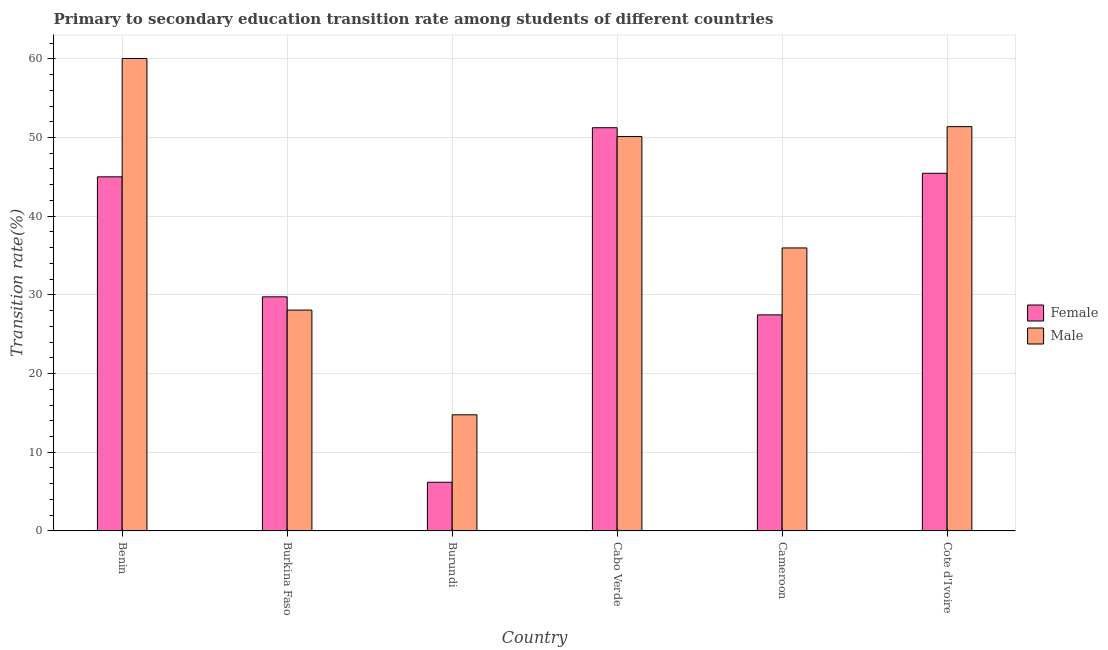How many groups of bars are there?
Offer a terse response. 6. Are the number of bars on each tick of the X-axis equal?
Offer a very short reply. Yes. How many bars are there on the 1st tick from the left?
Give a very brief answer. 2. How many bars are there on the 6th tick from the right?
Make the answer very short. 2. What is the label of the 2nd group of bars from the left?
Keep it short and to the point. Burkina Faso. What is the transition rate among male students in Cabo Verde?
Ensure brevity in your answer.  50.12. Across all countries, what is the maximum transition rate among female students?
Provide a succinct answer. 51.25. Across all countries, what is the minimum transition rate among female students?
Provide a succinct answer. 6.19. In which country was the transition rate among female students maximum?
Provide a succinct answer. Cabo Verde. In which country was the transition rate among male students minimum?
Make the answer very short. Burundi. What is the total transition rate among male students in the graph?
Provide a succinct answer. 240.34. What is the difference between the transition rate among male students in Benin and that in Cameroon?
Your answer should be compact. 24.08. What is the difference between the transition rate among female students in Burundi and the transition rate among male students in Cabo Verde?
Keep it short and to the point. -43.94. What is the average transition rate among male students per country?
Your answer should be very brief. 40.06. What is the difference between the transition rate among female students and transition rate among male students in Burkina Faso?
Your answer should be very brief. 1.69. What is the ratio of the transition rate among male students in Cameroon to that in Cote d'Ivoire?
Offer a terse response. 0.7. Is the transition rate among female students in Burundi less than that in Cabo Verde?
Ensure brevity in your answer.  Yes. Is the difference between the transition rate among male students in Burkina Faso and Cameroon greater than the difference between the transition rate among female students in Burkina Faso and Cameroon?
Your response must be concise. No. What is the difference between the highest and the second highest transition rate among female students?
Offer a terse response. 5.79. What is the difference between the highest and the lowest transition rate among female students?
Ensure brevity in your answer.  45.06. How many bars are there?
Give a very brief answer. 12. Are all the bars in the graph horizontal?
Your response must be concise. No. How many countries are there in the graph?
Ensure brevity in your answer.  6. Does the graph contain grids?
Provide a short and direct response. Yes. Where does the legend appear in the graph?
Make the answer very short. Center right. What is the title of the graph?
Keep it short and to the point. Primary to secondary education transition rate among students of different countries. What is the label or title of the Y-axis?
Offer a terse response. Transition rate(%). What is the Transition rate(%) in Female in Benin?
Your answer should be compact. 45. What is the Transition rate(%) in Male in Benin?
Offer a very short reply. 60.04. What is the Transition rate(%) in Female in Burkina Faso?
Offer a terse response. 29.76. What is the Transition rate(%) in Male in Burkina Faso?
Ensure brevity in your answer.  28.07. What is the Transition rate(%) of Female in Burundi?
Keep it short and to the point. 6.19. What is the Transition rate(%) of Male in Burundi?
Keep it short and to the point. 14.76. What is the Transition rate(%) in Female in Cabo Verde?
Your response must be concise. 51.25. What is the Transition rate(%) of Male in Cabo Verde?
Offer a very short reply. 50.12. What is the Transition rate(%) in Female in Cameroon?
Your response must be concise. 27.46. What is the Transition rate(%) in Male in Cameroon?
Your answer should be compact. 35.97. What is the Transition rate(%) of Female in Cote d'Ivoire?
Give a very brief answer. 45.46. What is the Transition rate(%) of Male in Cote d'Ivoire?
Offer a terse response. 51.38. Across all countries, what is the maximum Transition rate(%) of Female?
Your answer should be compact. 51.25. Across all countries, what is the maximum Transition rate(%) of Male?
Offer a terse response. 60.04. Across all countries, what is the minimum Transition rate(%) of Female?
Give a very brief answer. 6.19. Across all countries, what is the minimum Transition rate(%) in Male?
Provide a succinct answer. 14.76. What is the total Transition rate(%) in Female in the graph?
Offer a very short reply. 205.11. What is the total Transition rate(%) in Male in the graph?
Your answer should be very brief. 240.34. What is the difference between the Transition rate(%) of Female in Benin and that in Burkina Faso?
Offer a terse response. 15.25. What is the difference between the Transition rate(%) of Male in Benin and that in Burkina Faso?
Offer a terse response. 31.97. What is the difference between the Transition rate(%) in Female in Benin and that in Burundi?
Give a very brief answer. 38.82. What is the difference between the Transition rate(%) of Male in Benin and that in Burundi?
Offer a very short reply. 45.28. What is the difference between the Transition rate(%) in Female in Benin and that in Cabo Verde?
Make the answer very short. -6.24. What is the difference between the Transition rate(%) in Male in Benin and that in Cabo Verde?
Give a very brief answer. 9.92. What is the difference between the Transition rate(%) in Female in Benin and that in Cameroon?
Your answer should be very brief. 17.54. What is the difference between the Transition rate(%) of Male in Benin and that in Cameroon?
Ensure brevity in your answer.  24.08. What is the difference between the Transition rate(%) of Female in Benin and that in Cote d'Ivoire?
Offer a terse response. -0.45. What is the difference between the Transition rate(%) in Male in Benin and that in Cote d'Ivoire?
Your answer should be very brief. 8.66. What is the difference between the Transition rate(%) of Female in Burkina Faso and that in Burundi?
Provide a succinct answer. 23.57. What is the difference between the Transition rate(%) in Male in Burkina Faso and that in Burundi?
Give a very brief answer. 13.31. What is the difference between the Transition rate(%) of Female in Burkina Faso and that in Cabo Verde?
Ensure brevity in your answer.  -21.49. What is the difference between the Transition rate(%) in Male in Burkina Faso and that in Cabo Verde?
Ensure brevity in your answer.  -22.05. What is the difference between the Transition rate(%) in Female in Burkina Faso and that in Cameroon?
Your answer should be very brief. 2.29. What is the difference between the Transition rate(%) of Male in Burkina Faso and that in Cameroon?
Your answer should be compact. -7.9. What is the difference between the Transition rate(%) of Female in Burkina Faso and that in Cote d'Ivoire?
Your answer should be compact. -15.7. What is the difference between the Transition rate(%) of Male in Burkina Faso and that in Cote d'Ivoire?
Your answer should be very brief. -23.31. What is the difference between the Transition rate(%) of Female in Burundi and that in Cabo Verde?
Your answer should be compact. -45.06. What is the difference between the Transition rate(%) in Male in Burundi and that in Cabo Verde?
Your answer should be compact. -35.36. What is the difference between the Transition rate(%) of Female in Burundi and that in Cameroon?
Your answer should be compact. -21.27. What is the difference between the Transition rate(%) of Male in Burundi and that in Cameroon?
Make the answer very short. -21.21. What is the difference between the Transition rate(%) of Female in Burundi and that in Cote d'Ivoire?
Give a very brief answer. -39.27. What is the difference between the Transition rate(%) in Male in Burundi and that in Cote d'Ivoire?
Make the answer very short. -36.62. What is the difference between the Transition rate(%) of Female in Cabo Verde and that in Cameroon?
Provide a succinct answer. 23.79. What is the difference between the Transition rate(%) in Male in Cabo Verde and that in Cameroon?
Your answer should be very brief. 14.16. What is the difference between the Transition rate(%) of Female in Cabo Verde and that in Cote d'Ivoire?
Offer a very short reply. 5.79. What is the difference between the Transition rate(%) of Male in Cabo Verde and that in Cote d'Ivoire?
Keep it short and to the point. -1.26. What is the difference between the Transition rate(%) in Female in Cameroon and that in Cote d'Ivoire?
Give a very brief answer. -17.99. What is the difference between the Transition rate(%) of Male in Cameroon and that in Cote d'Ivoire?
Your response must be concise. -15.42. What is the difference between the Transition rate(%) in Female in Benin and the Transition rate(%) in Male in Burkina Faso?
Ensure brevity in your answer.  16.93. What is the difference between the Transition rate(%) in Female in Benin and the Transition rate(%) in Male in Burundi?
Offer a very short reply. 30.24. What is the difference between the Transition rate(%) in Female in Benin and the Transition rate(%) in Male in Cabo Verde?
Offer a terse response. -5.12. What is the difference between the Transition rate(%) of Female in Benin and the Transition rate(%) of Male in Cameroon?
Your answer should be very brief. 9.04. What is the difference between the Transition rate(%) of Female in Benin and the Transition rate(%) of Male in Cote d'Ivoire?
Offer a very short reply. -6.38. What is the difference between the Transition rate(%) in Female in Burkina Faso and the Transition rate(%) in Male in Burundi?
Your answer should be compact. 15. What is the difference between the Transition rate(%) in Female in Burkina Faso and the Transition rate(%) in Male in Cabo Verde?
Give a very brief answer. -20.37. What is the difference between the Transition rate(%) of Female in Burkina Faso and the Transition rate(%) of Male in Cameroon?
Ensure brevity in your answer.  -6.21. What is the difference between the Transition rate(%) of Female in Burkina Faso and the Transition rate(%) of Male in Cote d'Ivoire?
Offer a terse response. -21.63. What is the difference between the Transition rate(%) of Female in Burundi and the Transition rate(%) of Male in Cabo Verde?
Make the answer very short. -43.94. What is the difference between the Transition rate(%) in Female in Burundi and the Transition rate(%) in Male in Cameroon?
Your response must be concise. -29.78. What is the difference between the Transition rate(%) in Female in Burundi and the Transition rate(%) in Male in Cote d'Ivoire?
Provide a succinct answer. -45.19. What is the difference between the Transition rate(%) of Female in Cabo Verde and the Transition rate(%) of Male in Cameroon?
Offer a very short reply. 15.28. What is the difference between the Transition rate(%) in Female in Cabo Verde and the Transition rate(%) in Male in Cote d'Ivoire?
Your response must be concise. -0.14. What is the difference between the Transition rate(%) of Female in Cameroon and the Transition rate(%) of Male in Cote d'Ivoire?
Offer a terse response. -23.92. What is the average Transition rate(%) in Female per country?
Make the answer very short. 34.18. What is the average Transition rate(%) in Male per country?
Ensure brevity in your answer.  40.06. What is the difference between the Transition rate(%) of Female and Transition rate(%) of Male in Benin?
Your answer should be very brief. -15.04. What is the difference between the Transition rate(%) in Female and Transition rate(%) in Male in Burkina Faso?
Your answer should be very brief. 1.69. What is the difference between the Transition rate(%) in Female and Transition rate(%) in Male in Burundi?
Provide a short and direct response. -8.57. What is the difference between the Transition rate(%) of Female and Transition rate(%) of Male in Cabo Verde?
Offer a very short reply. 1.12. What is the difference between the Transition rate(%) of Female and Transition rate(%) of Male in Cameroon?
Keep it short and to the point. -8.5. What is the difference between the Transition rate(%) in Female and Transition rate(%) in Male in Cote d'Ivoire?
Make the answer very short. -5.93. What is the ratio of the Transition rate(%) of Female in Benin to that in Burkina Faso?
Provide a succinct answer. 1.51. What is the ratio of the Transition rate(%) in Male in Benin to that in Burkina Faso?
Your answer should be compact. 2.14. What is the ratio of the Transition rate(%) of Female in Benin to that in Burundi?
Your answer should be compact. 7.27. What is the ratio of the Transition rate(%) in Male in Benin to that in Burundi?
Make the answer very short. 4.07. What is the ratio of the Transition rate(%) in Female in Benin to that in Cabo Verde?
Your answer should be very brief. 0.88. What is the ratio of the Transition rate(%) of Male in Benin to that in Cabo Verde?
Provide a succinct answer. 1.2. What is the ratio of the Transition rate(%) of Female in Benin to that in Cameroon?
Provide a short and direct response. 1.64. What is the ratio of the Transition rate(%) in Male in Benin to that in Cameroon?
Offer a terse response. 1.67. What is the ratio of the Transition rate(%) in Female in Benin to that in Cote d'Ivoire?
Ensure brevity in your answer.  0.99. What is the ratio of the Transition rate(%) of Male in Benin to that in Cote d'Ivoire?
Provide a short and direct response. 1.17. What is the ratio of the Transition rate(%) of Female in Burkina Faso to that in Burundi?
Offer a terse response. 4.81. What is the ratio of the Transition rate(%) of Male in Burkina Faso to that in Burundi?
Ensure brevity in your answer.  1.9. What is the ratio of the Transition rate(%) in Female in Burkina Faso to that in Cabo Verde?
Provide a short and direct response. 0.58. What is the ratio of the Transition rate(%) in Male in Burkina Faso to that in Cabo Verde?
Offer a very short reply. 0.56. What is the ratio of the Transition rate(%) of Female in Burkina Faso to that in Cameroon?
Provide a succinct answer. 1.08. What is the ratio of the Transition rate(%) in Male in Burkina Faso to that in Cameroon?
Make the answer very short. 0.78. What is the ratio of the Transition rate(%) of Female in Burkina Faso to that in Cote d'Ivoire?
Your answer should be very brief. 0.65. What is the ratio of the Transition rate(%) in Male in Burkina Faso to that in Cote d'Ivoire?
Keep it short and to the point. 0.55. What is the ratio of the Transition rate(%) of Female in Burundi to that in Cabo Verde?
Provide a succinct answer. 0.12. What is the ratio of the Transition rate(%) of Male in Burundi to that in Cabo Verde?
Make the answer very short. 0.29. What is the ratio of the Transition rate(%) in Female in Burundi to that in Cameroon?
Your answer should be very brief. 0.23. What is the ratio of the Transition rate(%) in Male in Burundi to that in Cameroon?
Your answer should be compact. 0.41. What is the ratio of the Transition rate(%) in Female in Burundi to that in Cote d'Ivoire?
Ensure brevity in your answer.  0.14. What is the ratio of the Transition rate(%) of Male in Burundi to that in Cote d'Ivoire?
Your answer should be very brief. 0.29. What is the ratio of the Transition rate(%) in Female in Cabo Verde to that in Cameroon?
Offer a terse response. 1.87. What is the ratio of the Transition rate(%) in Male in Cabo Verde to that in Cameroon?
Offer a terse response. 1.39. What is the ratio of the Transition rate(%) in Female in Cabo Verde to that in Cote d'Ivoire?
Provide a short and direct response. 1.13. What is the ratio of the Transition rate(%) of Male in Cabo Verde to that in Cote d'Ivoire?
Your answer should be compact. 0.98. What is the ratio of the Transition rate(%) in Female in Cameroon to that in Cote d'Ivoire?
Offer a terse response. 0.6. What is the difference between the highest and the second highest Transition rate(%) of Female?
Provide a succinct answer. 5.79. What is the difference between the highest and the second highest Transition rate(%) in Male?
Offer a very short reply. 8.66. What is the difference between the highest and the lowest Transition rate(%) of Female?
Provide a short and direct response. 45.06. What is the difference between the highest and the lowest Transition rate(%) of Male?
Your answer should be very brief. 45.28. 